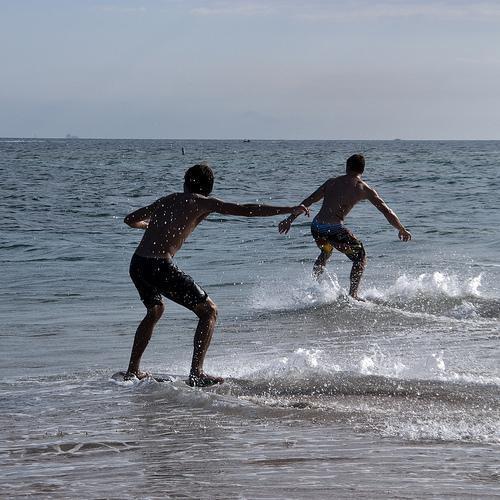How many people are there?
Give a very brief answer. 2. 